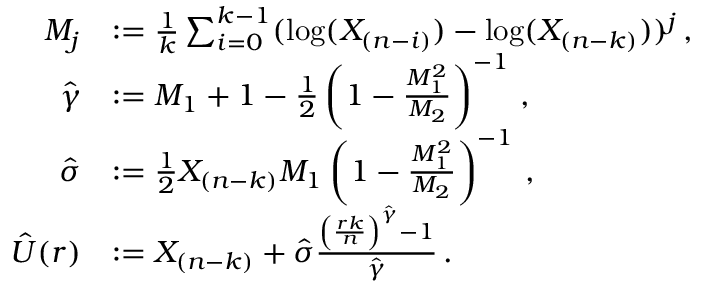<formula> <loc_0><loc_0><loc_500><loc_500>\begin{array} { r l } { M _ { j } } & { \colon = \frac { 1 } { k } \sum _ { i = 0 } ^ { k - 1 } ( \log ( X _ { ( n - i ) } ) - \log ( X _ { ( n - k ) } ) ) ^ { j } \, , } \\ { \hat { \gamma } } & { \colon = M _ { 1 } + 1 - \frac { 1 } { 2 } \left ( 1 - \frac { M _ { 1 } ^ { 2 } } { M _ { 2 } } \right ) ^ { - 1 } \, , } \\ { \hat { \sigma } } & { \colon = \frac { 1 } { 2 } X _ { ( n - k ) } M _ { 1 } \left ( 1 - \frac { M _ { 1 } ^ { 2 } } { M _ { 2 } } \right ) ^ { - 1 } \, , } \\ { \hat { U } ( r ) } & { \colon = X _ { ( n - k ) } + \hat { \sigma } \frac { \left ( \frac { r k } { n } \right ) ^ { \hat { \gamma } } - 1 } { \hat { \gamma } } \, . } \end{array}</formula> 